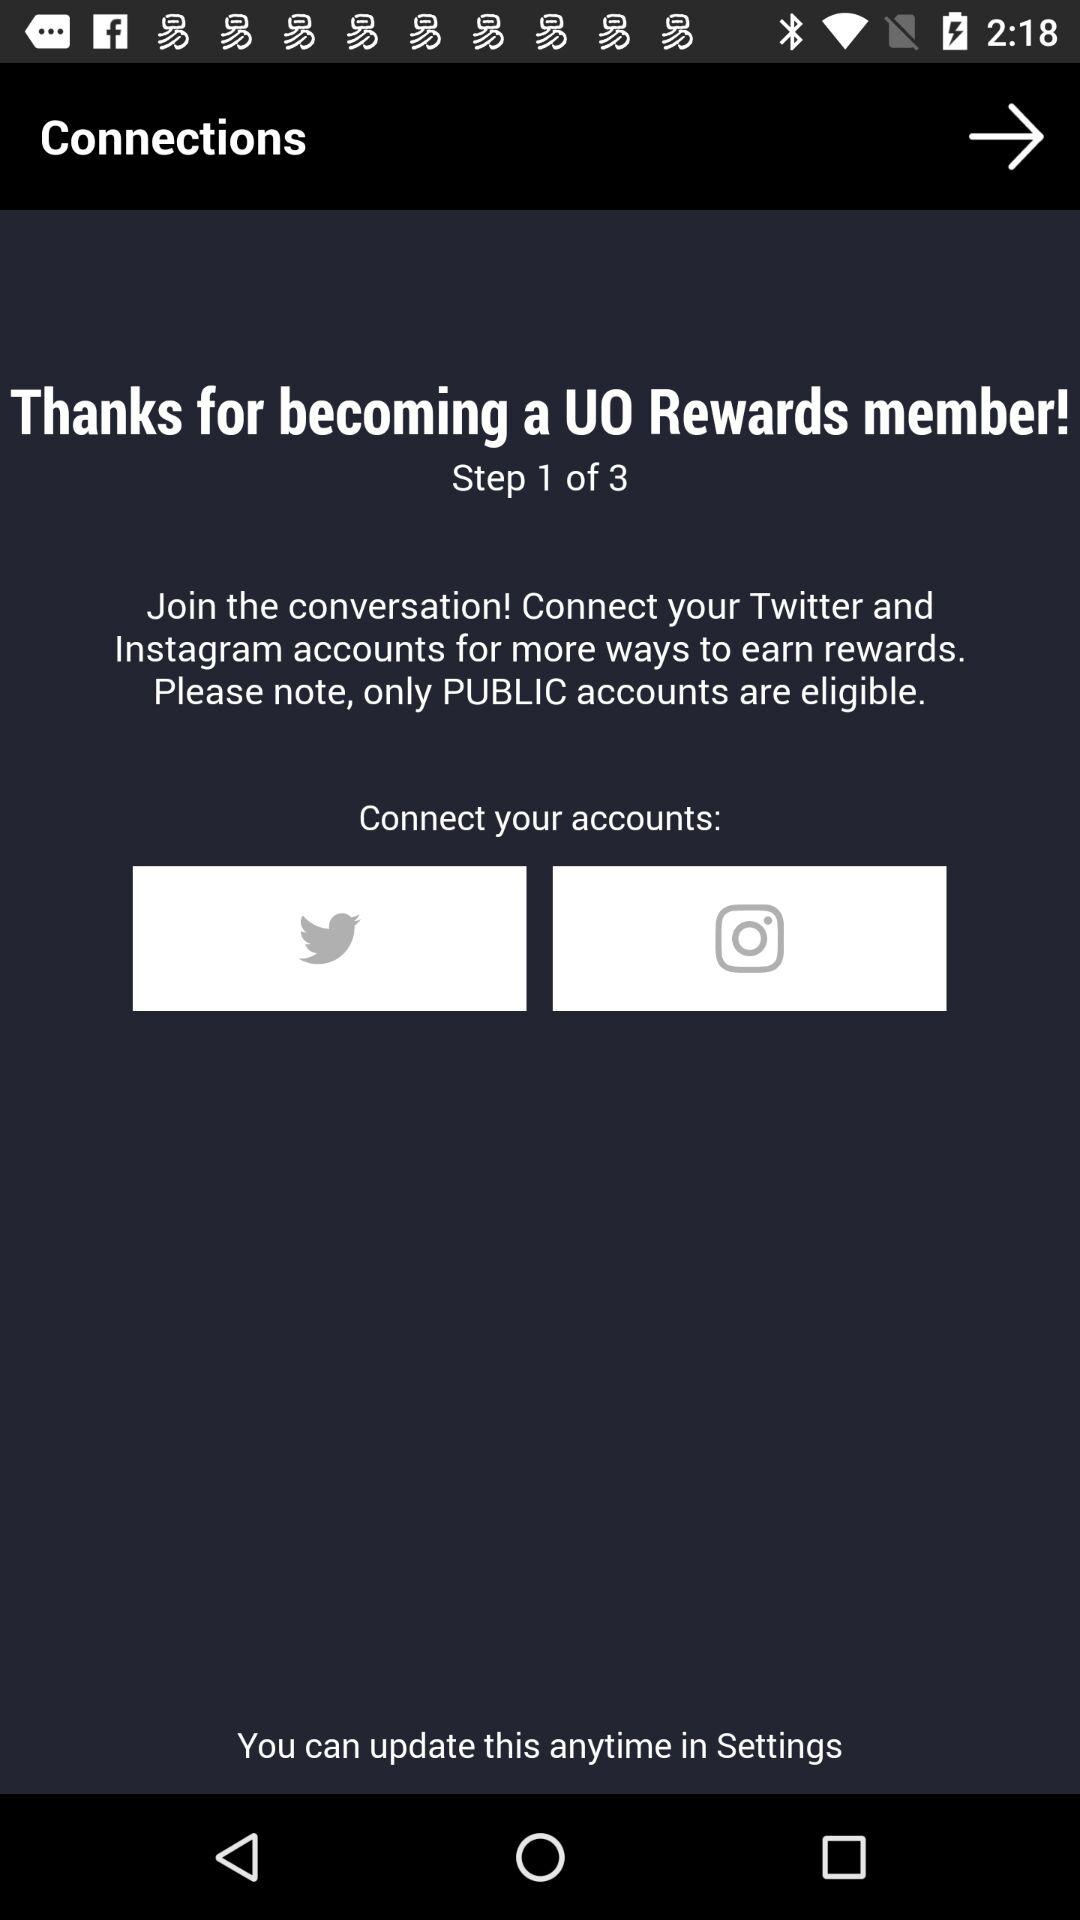What's the total number of steps? The total number of steps is 3. 